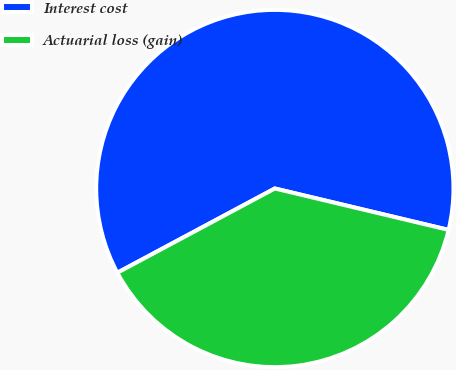Convert chart. <chart><loc_0><loc_0><loc_500><loc_500><pie_chart><fcel>Interest cost<fcel>Actuarial loss (gain)<nl><fcel>61.54%<fcel>38.46%<nl></chart> 